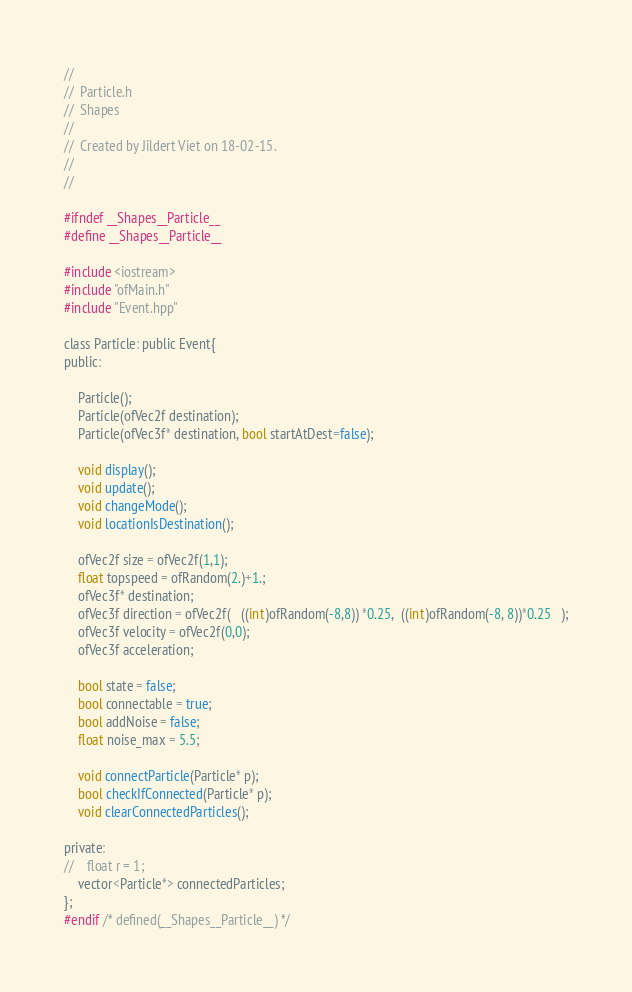<code> <loc_0><loc_0><loc_500><loc_500><_C_>//
//  Particle.h
//  Shapes
//
//  Created by Jildert Viet on 18-02-15.
//
//

#ifndef __Shapes__Particle__
#define __Shapes__Particle__

#include <iostream>
#include "ofMain.h"
#include "Event.hpp"

class Particle: public Event{
public:
    
    Particle();
    Particle(ofVec2f destination);
    Particle(ofVec3f* destination, bool startAtDest=false);
    
    void display();
    void update();
    void changeMode();
    void locationIsDestination();
    
    ofVec2f size = ofVec2f(1,1);
    float topspeed = ofRandom(2.)+1.;
    ofVec3f* destination;
    ofVec3f direction = ofVec2f(   ((int)ofRandom(-8,8)) *0.25,  ((int)ofRandom(-8, 8))*0.25   );
    ofVec3f velocity = ofVec2f(0,0);
    ofVec3f acceleration;
    
    bool state = false;
    bool connectable = true;
    bool addNoise = false;
    float noise_max = 5.5;
        
    void connectParticle(Particle* p);
    bool checkIfConnected(Particle* p);
    void clearConnectedParticles();
    
private:
//    float r = 1;
    vector<Particle*> connectedParticles;
};
#endif /* defined(__Shapes__Particle__) */
</code> 